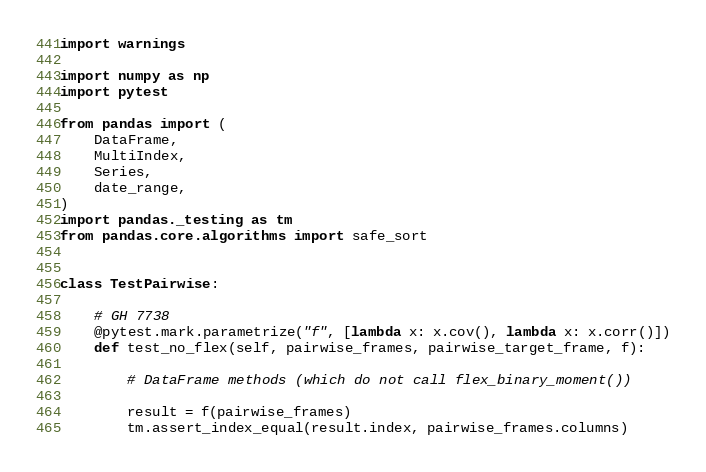<code> <loc_0><loc_0><loc_500><loc_500><_Python_>import warnings

import numpy as np
import pytest

from pandas import (
    DataFrame,
    MultiIndex,
    Series,
    date_range,
)
import pandas._testing as tm
from pandas.core.algorithms import safe_sort


class TestPairwise:

    # GH 7738
    @pytest.mark.parametrize("f", [lambda x: x.cov(), lambda x: x.corr()])
    def test_no_flex(self, pairwise_frames, pairwise_target_frame, f):

        # DataFrame methods (which do not call flex_binary_moment())

        result = f(pairwise_frames)
        tm.assert_index_equal(result.index, pairwise_frames.columns)</code> 